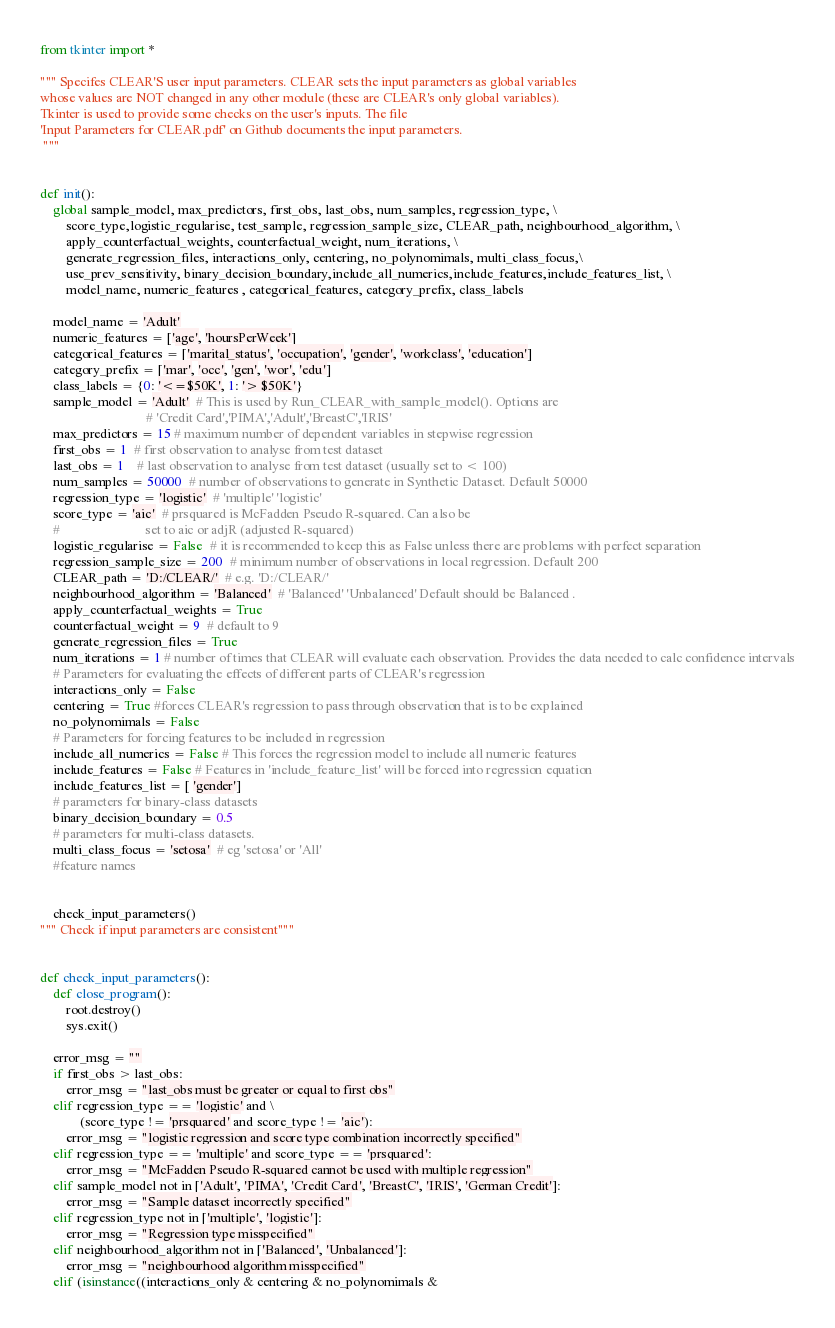<code> <loc_0><loc_0><loc_500><loc_500><_Python_>from tkinter import *

""" Specifes CLEAR'S user input parameters. CLEAR sets the input parameters as global variables
whose values are NOT changed in any other module (these are CLEAR's only global variables).
Tkinter is used to provide some checks on the user's inputs. The file 
'Input Parameters for CLEAR.pdf' on Github documents the input parameters.
 """


def init():
    global sample_model, max_predictors, first_obs, last_obs, num_samples, regression_type, \
        score_type,logistic_regularise, test_sample, regression_sample_size, CLEAR_path, neighbourhood_algorithm, \
        apply_counterfactual_weights, counterfactual_weight, num_iterations, \
        generate_regression_files, interactions_only, centering, no_polynomimals, multi_class_focus,\
        use_prev_sensitivity, binary_decision_boundary,include_all_numerics,include_features,include_features_list, \
        model_name, numeric_features , categorical_features, category_prefix, class_labels

    model_name = 'Adult'
    numeric_features = ['age', 'hoursPerWeek']
    categorical_features = ['marital_status', 'occupation', 'gender', 'workclass', 'education']
    category_prefix = ['mar', 'occ', 'gen', 'wor', 'edu']
    class_labels = {0: '<=$50K', 1: '> $50K'}
    sample_model = 'Adult'  # This is used by Run_CLEAR_with_sample_model(). Options are
                                # 'Credit Card','PIMA','Adult','BreastC','IRIS'
    max_predictors = 15 # maximum number of dependent variables in stepwise regression
    first_obs = 1  # first observation to analyse from test dataset
    last_obs = 1    # last observation to analyse from test dataset (usually set to < 100)
    num_samples = 50000  # number of observations to generate in Synthetic Dataset. Default 50000
    regression_type = 'logistic'  # 'multiple' 'logistic'
    score_type = 'aic'  # prsquared is McFadden Pseudo R-squared. Can also be
    #                          set to aic or adjR (adjusted R-squared)
    logistic_regularise = False  # it is recommended to keep this as False unless there are problems with perfect separation
    regression_sample_size = 200  # minimum number of observations in local regression. Default 200
    CLEAR_path = 'D:/CLEAR/'  # e.g. 'D:/CLEAR/'
    neighbourhood_algorithm = 'Balanced'  # 'Balanced' 'Unbalanced' Default should be Balanced .
    apply_counterfactual_weights = True
    counterfactual_weight = 9  # default to 9
    generate_regression_files = True
    num_iterations = 1 # number of times that CLEAR will evaluate each observation. Provides the data needed to calc confidence intervals
    # Parameters for evaluating the effects of different parts of CLEAR's regression
    interactions_only = False
    centering = True #forces CLEAR's regression to pass through observation that is to be explained
    no_polynomimals = False
    # Parameters for forcing features to be included in regression
    include_all_numerics = False # This forces the regression model to include all numeric features
    include_features = False # Features in 'include_feature_list' will be forced into regression equation
    include_features_list = [ 'gender']
    # parameters for binary-class datasets
    binary_decision_boundary = 0.5
    # parameters for multi-class datasets.
    multi_class_focus = 'setosa'  # eg 'setosa' or 'All'
    #feature names


    check_input_parameters()
""" Check if input parameters are consistent"""


def check_input_parameters():
    def close_program():
        root.destroy()
        sys.exit()

    error_msg = ""
    if first_obs > last_obs:
        error_msg = "last_obs must be greater or equal to first obs"
    elif regression_type == 'logistic' and \
            (score_type != 'prsquared' and score_type != 'aic'):
        error_msg = "logistic regression and score type combination incorrectly specified"
    elif regression_type == 'multiple' and score_type == 'prsquared':
        error_msg = "McFadden Pseudo R-squared cannot be used with multiple regression"
    elif sample_model not in ['Adult', 'PIMA', 'Credit Card', 'BreastC', 'IRIS', 'German Credit']:
        error_msg = "Sample dataset incorrectly specified"
    elif regression_type not in ['multiple', 'logistic']:
        error_msg = "Regression type misspecified"
    elif neighbourhood_algorithm not in ['Balanced', 'Unbalanced']:
        error_msg = "neighbourhood algorithm misspecified"
    elif (isinstance((interactions_only & centering & no_polynomimals &</code> 